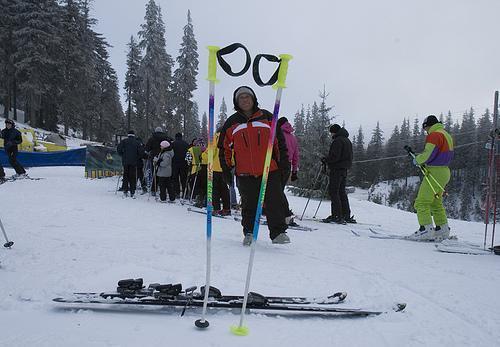How many people are there?
Give a very brief answer. 2. How many cows are in the field?
Give a very brief answer. 0. 